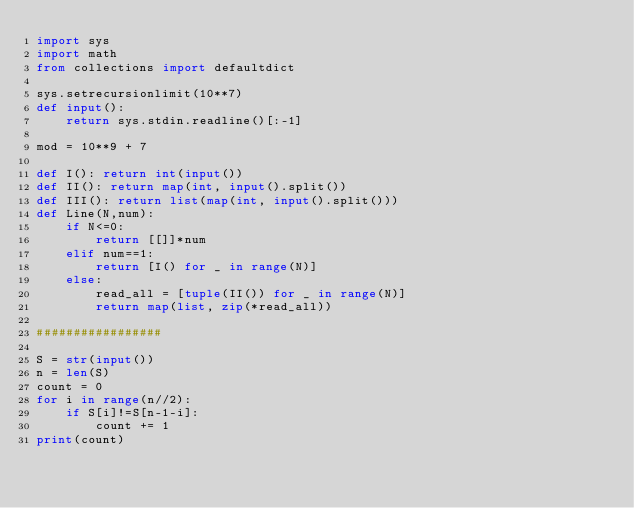<code> <loc_0><loc_0><loc_500><loc_500><_Python_>import sys
import math
from collections import defaultdict

sys.setrecursionlimit(10**7)
def input():
    return sys.stdin.readline()[:-1]

mod = 10**9 + 7

def I(): return int(input())
def II(): return map(int, input().split())
def III(): return list(map(int, input().split()))
def Line(N,num):
    if N<=0:
        return [[]]*num
    elif num==1:
        return [I() for _ in range(N)]
    else:
        read_all = [tuple(II()) for _ in range(N)]
        return map(list, zip(*read_all))

#################

S = str(input())
n = len(S)
count = 0
for i in range(n//2):
    if S[i]!=S[n-1-i]:
        count += 1
print(count)</code> 